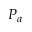<formula> <loc_0><loc_0><loc_500><loc_500>P _ { a }</formula> 